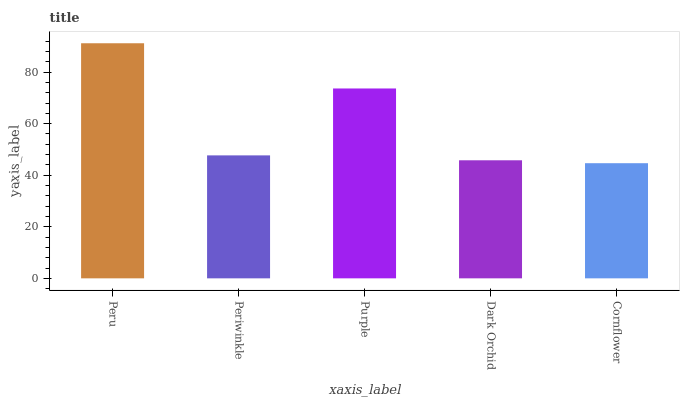Is Cornflower the minimum?
Answer yes or no. Yes. Is Peru the maximum?
Answer yes or no. Yes. Is Periwinkle the minimum?
Answer yes or no. No. Is Periwinkle the maximum?
Answer yes or no. No. Is Peru greater than Periwinkle?
Answer yes or no. Yes. Is Periwinkle less than Peru?
Answer yes or no. Yes. Is Periwinkle greater than Peru?
Answer yes or no. No. Is Peru less than Periwinkle?
Answer yes or no. No. Is Periwinkle the high median?
Answer yes or no. Yes. Is Periwinkle the low median?
Answer yes or no. Yes. Is Peru the high median?
Answer yes or no. No. Is Peru the low median?
Answer yes or no. No. 